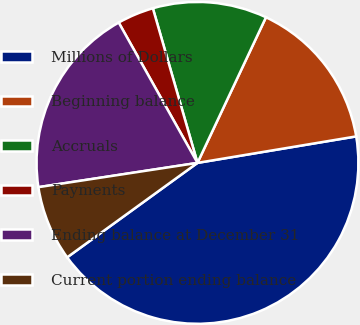<chart> <loc_0><loc_0><loc_500><loc_500><pie_chart><fcel>Millions of Dollars<fcel>Beginning balance<fcel>Accruals<fcel>Payments<fcel>Ending balance at December 31<fcel>Current portion ending balance<nl><fcel>42.65%<fcel>15.37%<fcel>11.47%<fcel>3.67%<fcel>19.27%<fcel>7.57%<nl></chart> 